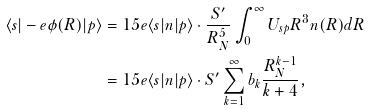Convert formula to latex. <formula><loc_0><loc_0><loc_500><loc_500>\langle s | - e \phi ( { R } ) | p \rangle & = 1 5 e \langle s | { n } | p \rangle \cdot \frac { S ^ { \prime } } { R _ { N } ^ { 5 } } \int _ { 0 } ^ { \infty } U _ { s p } R ^ { 3 } n ( R ) d R \\ & = 1 5 e \langle s | { n } | p \rangle \cdot { S ^ { \prime } } \sum _ { k = 1 } ^ { \infty } b _ { k } \frac { R _ { N } ^ { k - 1 } } { k + 4 } ,</formula> 